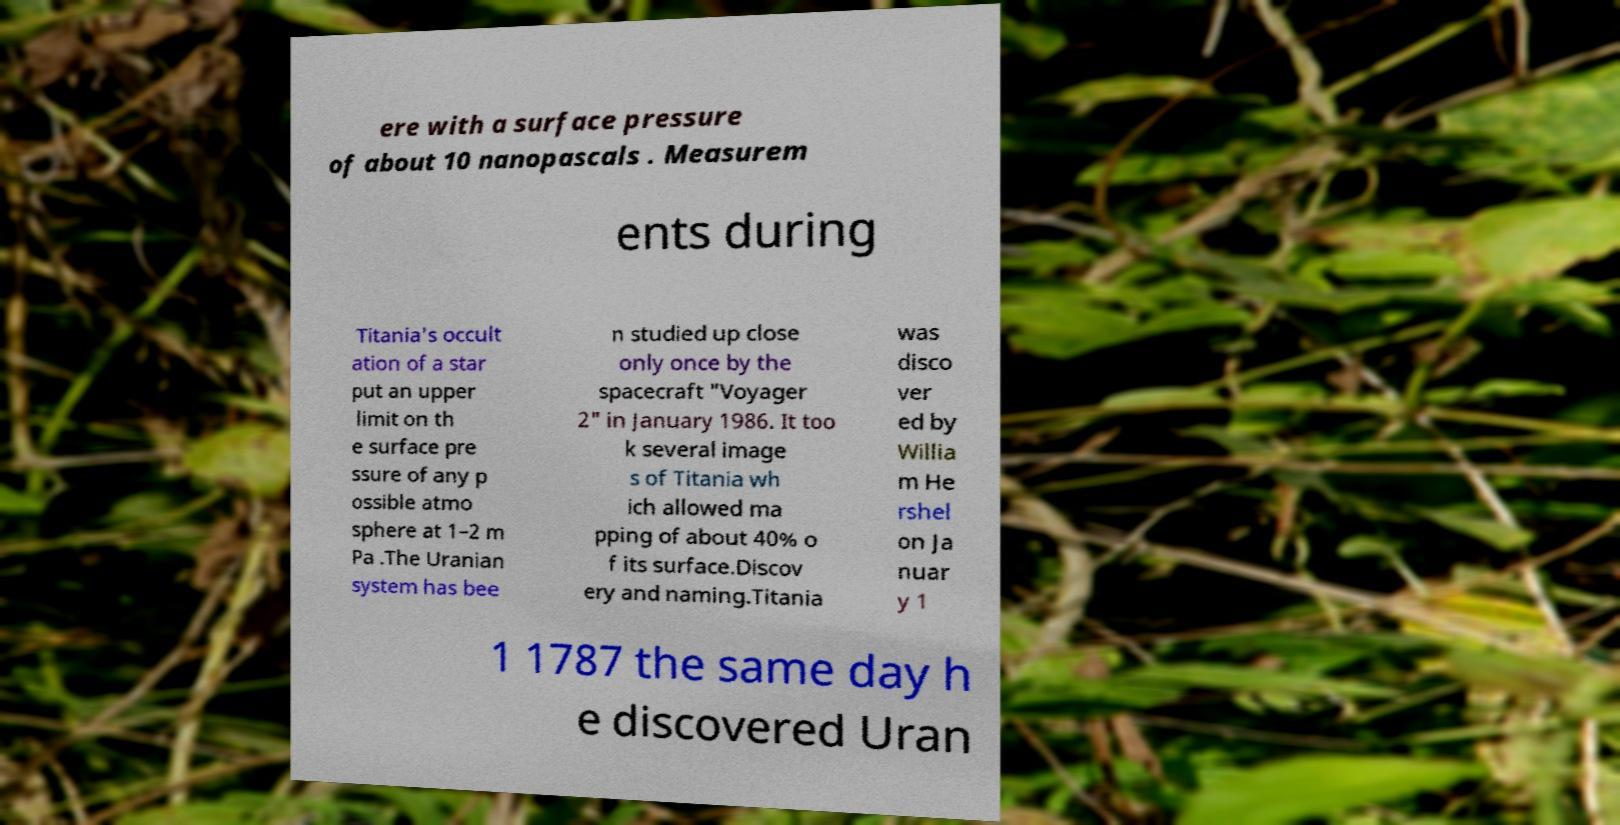Could you assist in decoding the text presented in this image and type it out clearly? ere with a surface pressure of about 10 nanopascals . Measurem ents during Titania's occult ation of a star put an upper limit on th e surface pre ssure of any p ossible atmo sphere at 1–2 m Pa .The Uranian system has bee n studied up close only once by the spacecraft "Voyager 2" in January 1986. It too k several image s of Titania wh ich allowed ma pping of about 40% o f its surface.Discov ery and naming.Titania was disco ver ed by Willia m He rshel on Ja nuar y 1 1 1787 the same day h e discovered Uran 